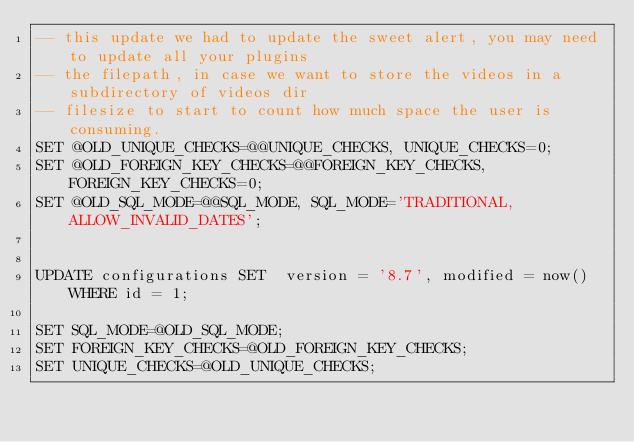Convert code to text. <code><loc_0><loc_0><loc_500><loc_500><_SQL_>-- this update we had to update the sweet alert, you may need to update all your plugins
-- the filepath, in case we want to store the videos in a subdirectory of videos dir
-- filesize to start to count how much space the user is consuming.
SET @OLD_UNIQUE_CHECKS=@@UNIQUE_CHECKS, UNIQUE_CHECKS=0;
SET @OLD_FOREIGN_KEY_CHECKS=@@FOREIGN_KEY_CHECKS, FOREIGN_KEY_CHECKS=0;
SET @OLD_SQL_MODE=@@SQL_MODE, SQL_MODE='TRADITIONAL,ALLOW_INVALID_DATES';


UPDATE configurations SET  version = '8.7', modified = now() WHERE id = 1;

SET SQL_MODE=@OLD_SQL_MODE;
SET FOREIGN_KEY_CHECKS=@OLD_FOREIGN_KEY_CHECKS;
SET UNIQUE_CHECKS=@OLD_UNIQUE_CHECKS;
</code> 